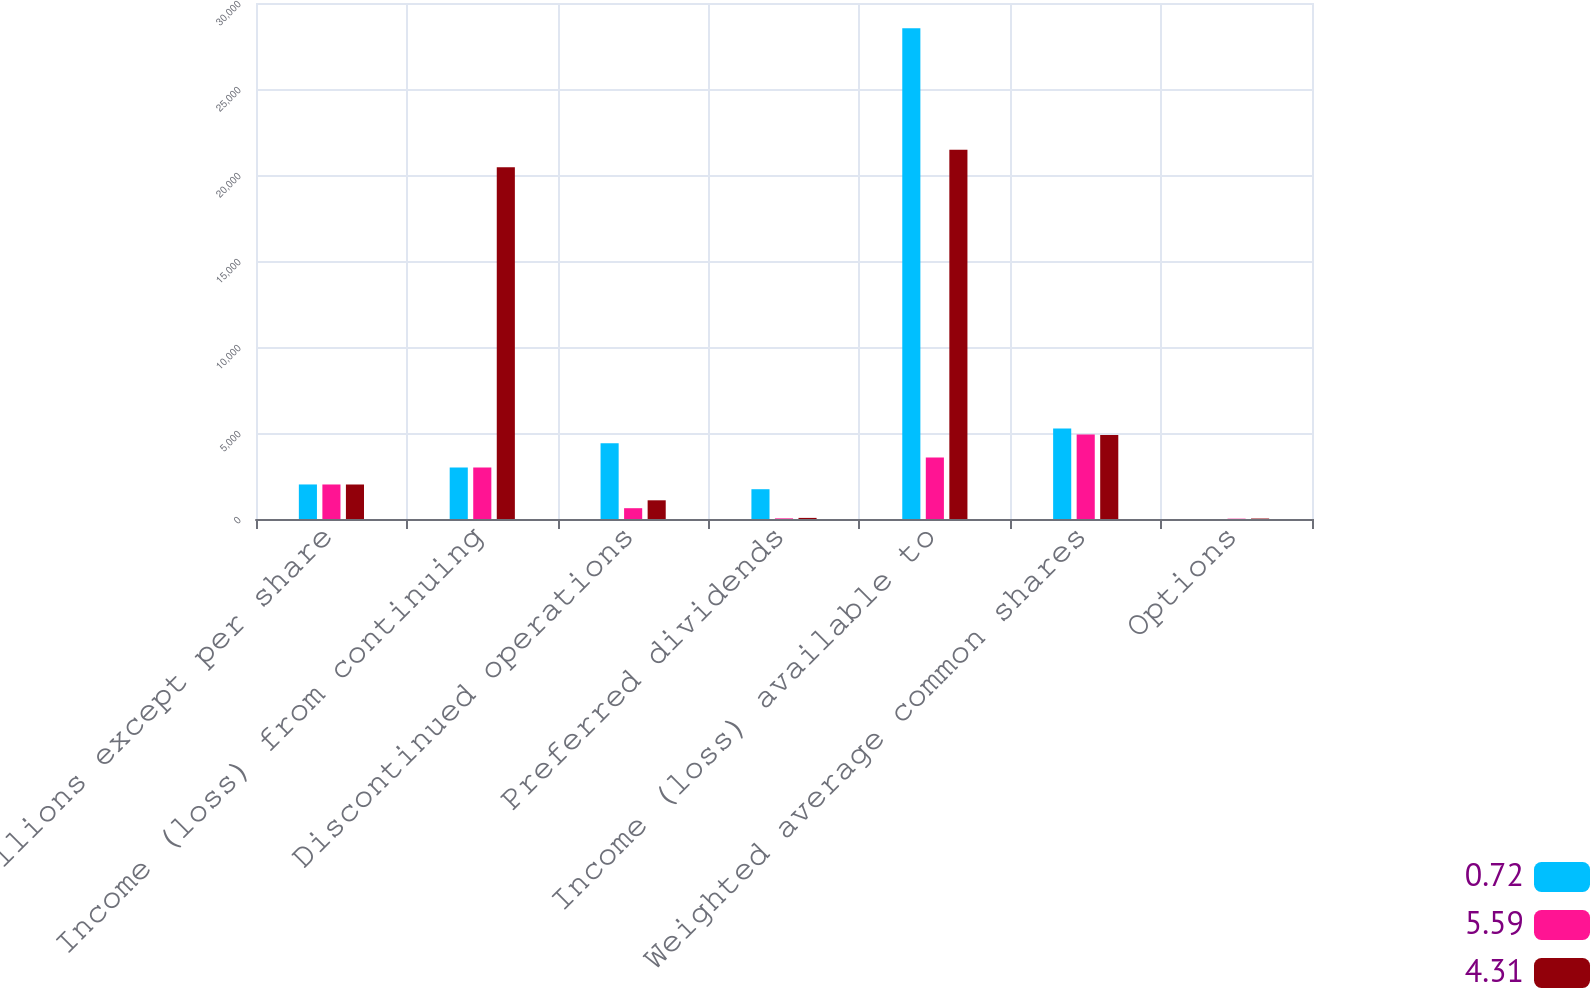<chart> <loc_0><loc_0><loc_500><loc_500><stacked_bar_chart><ecel><fcel>In millions except per share<fcel>Income (loss) from continuing<fcel>Discontinued operations<fcel>Preferred dividends<fcel>Income (loss) available to<fcel>Weighted average common shares<fcel>Options<nl><fcel>0.72<fcel>2008<fcel>2989<fcel>4410<fcel>1732<fcel>28539<fcel>5265.4<fcel>0.3<nl><fcel>5.59<fcel>2007<fcel>2989<fcel>628<fcel>36<fcel>3581<fcel>4905.8<fcel>18.2<nl><fcel>4.31<fcel>2006<fcel>20451<fcel>1087<fcel>64<fcel>21474<fcel>4887.3<fcel>27.2<nl></chart> 